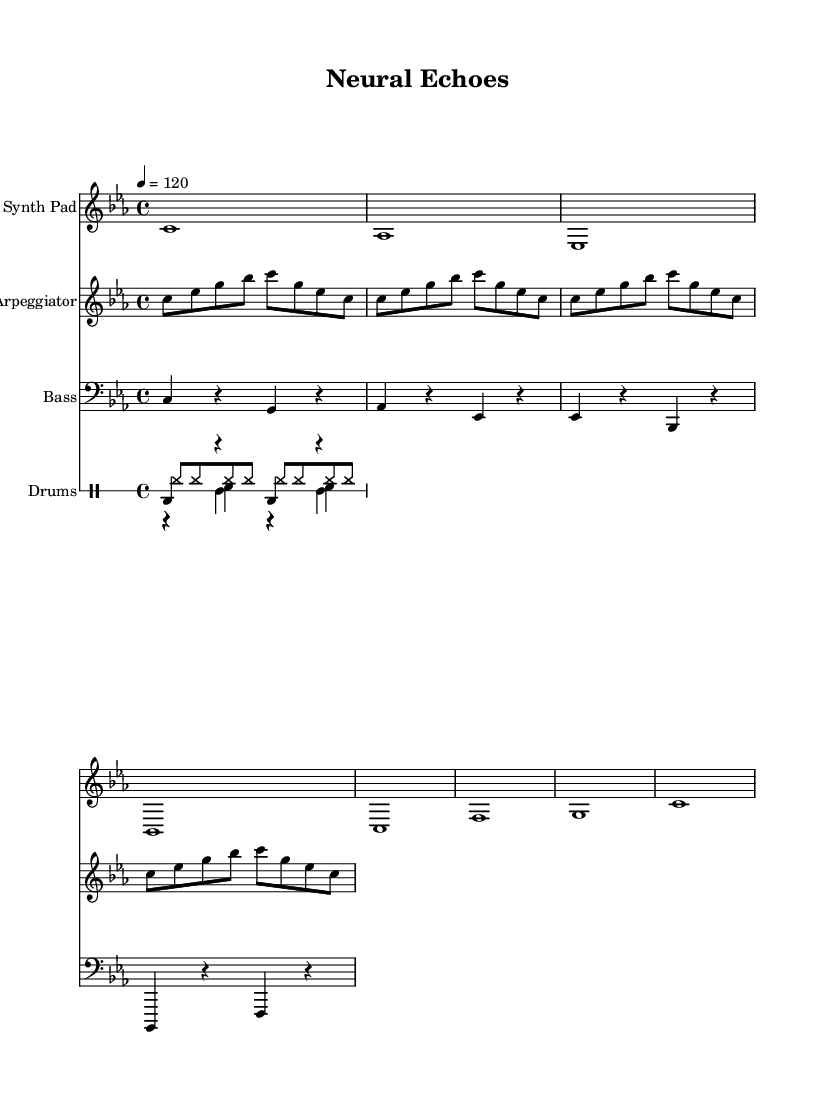What is the key signature of this music? The key signature is indicated at the beginning of the score, showing three flats, which means the piece is in C minor.
Answer: C minor What is the time signature of this piece? The time signature is located near the beginning of the music after the key signature, and it shows a 4 over 4, indicating four beats per measure.
Answer: 4/4 What is the tempo marking in this score? The tempo marking is found next to the time signature and indicates that the piece should be played at a speed of 120 beats per minute. It is indicated in the code with "4 = 120".
Answer: 120 How many measures are in the "Synth Pad" section? To determine the number of measures in the Synth Pad section, we look at the number of vertical lines separating the musical phrases. There are 8 measures present.
Answer: 8 Which instruments are used in this piece? The instruments are specified in the score, and we have Synth Pad, Arpeggiator, Bass, and Drums. Each is indicated by a new staff in the score.
Answer: Synth Pad, Arpeggiator, Bass, Drums What type of drum patterns are used in this piece? The drum section includes a kick, snare, hi-hat, and clap patterns. The patterns and their specific rhythms can be identified by the drum notation and are common in house music.
Answer: Kick, Snare, Hi-hat, Clap Which musical element introduces rhythmic variation in the piece? The arpeggiator section, with its repeating and slightly varied notes, introduces rhythmic variation to complement the harmonic and melodic elements of the piece, often used in house music to create texture.
Answer: Arpeggiator 